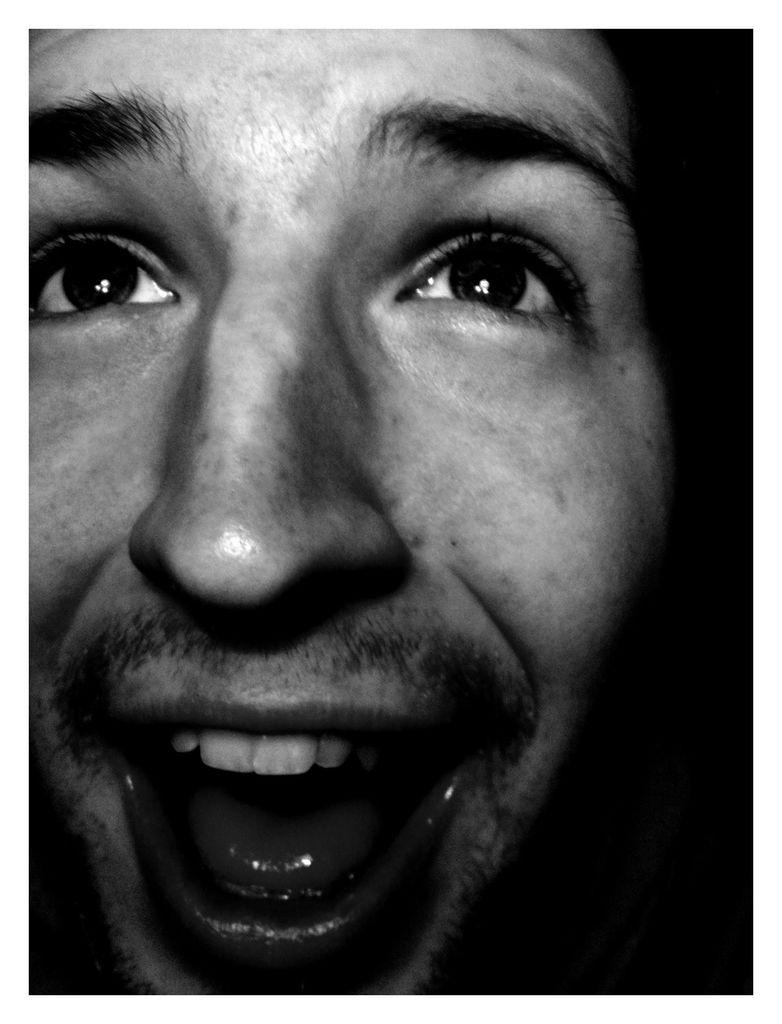What is the main subject of the image? There is a man in the image. What is the man's facial expression? The man is smiling. How would you describe the lighting on the right side of the image? The right side of the image appears to be dark. What type of kite is the man flying in the image? There is no kite present in the image; it only features a man who is smiling. Can you see any flames in the image? There are no flames visible in the image. 